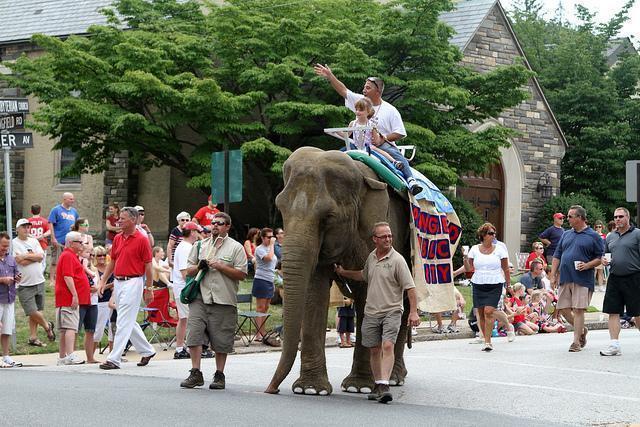What is the long fabric item hanging down the elephant's side?
From the following set of four choices, select the accurate answer to respond to the question.
Options: Blanket, curtain, banner, flag. Banner. 